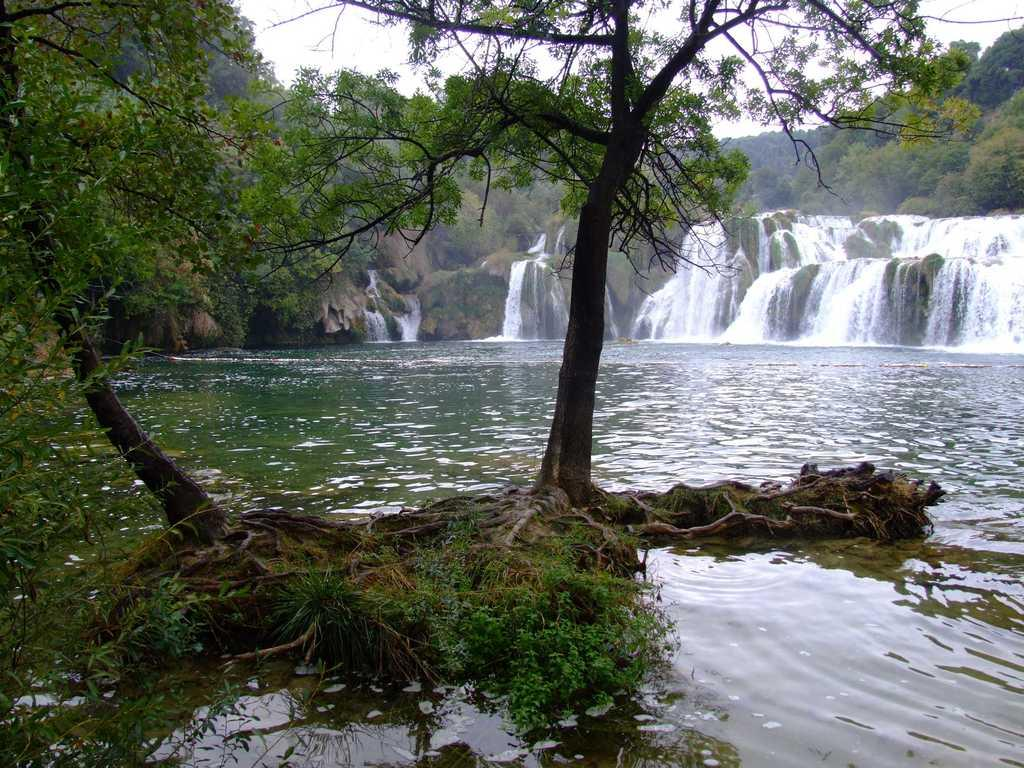What can be seen in the foreground of the image? There are trees and water in the foreground of the image. What natural features are present in the image? There are waterfalls in the image. What can be seen in the background of the image? It appears that there are mountains in the background of the image, and the sky is visible as well. How many seeds can be seen on the waterfall in the image? A: There are no seeds present in the image, as it features trees, water, waterfalls, mountains, and the sky. Is there a pig visible in the image? No, there is no pig present in the image. 